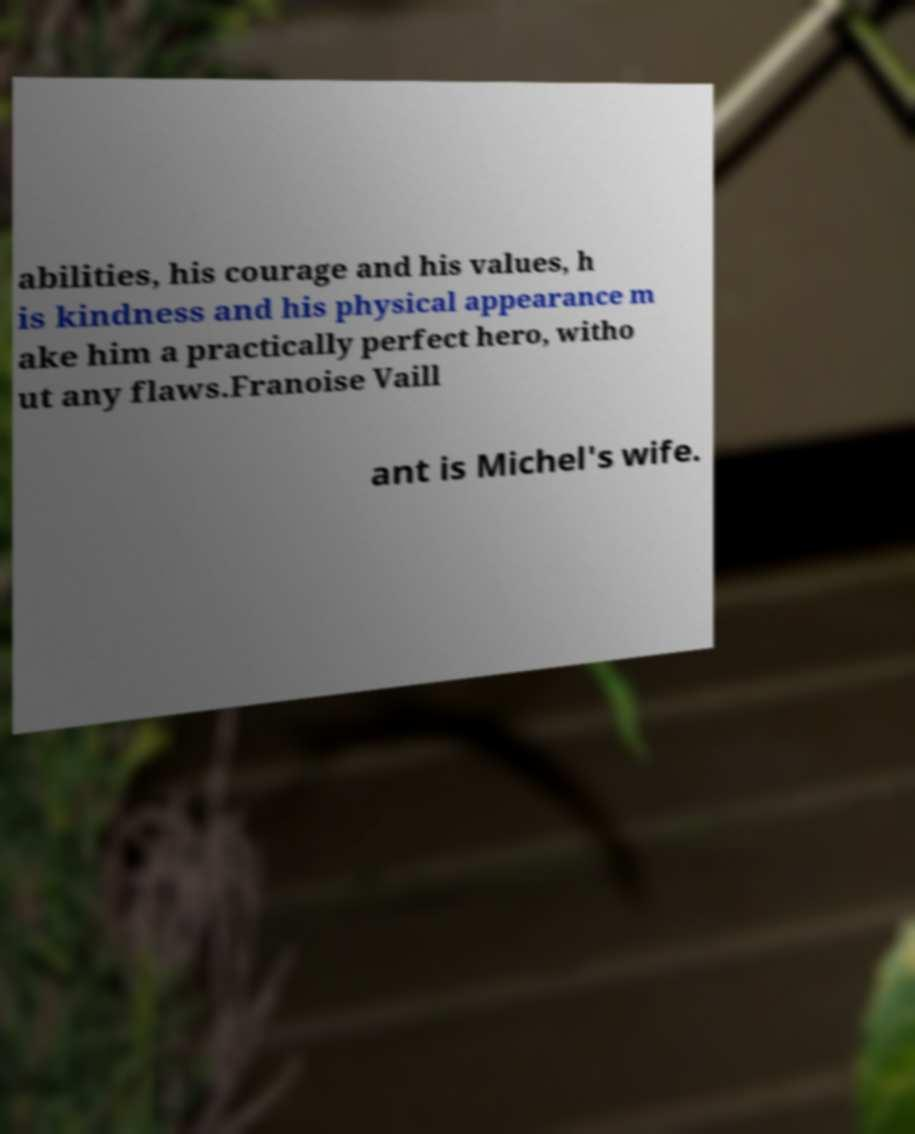There's text embedded in this image that I need extracted. Can you transcribe it verbatim? abilities, his courage and his values, h is kindness and his physical appearance m ake him a practically perfect hero, witho ut any flaws.Franoise Vaill ant is Michel's wife. 